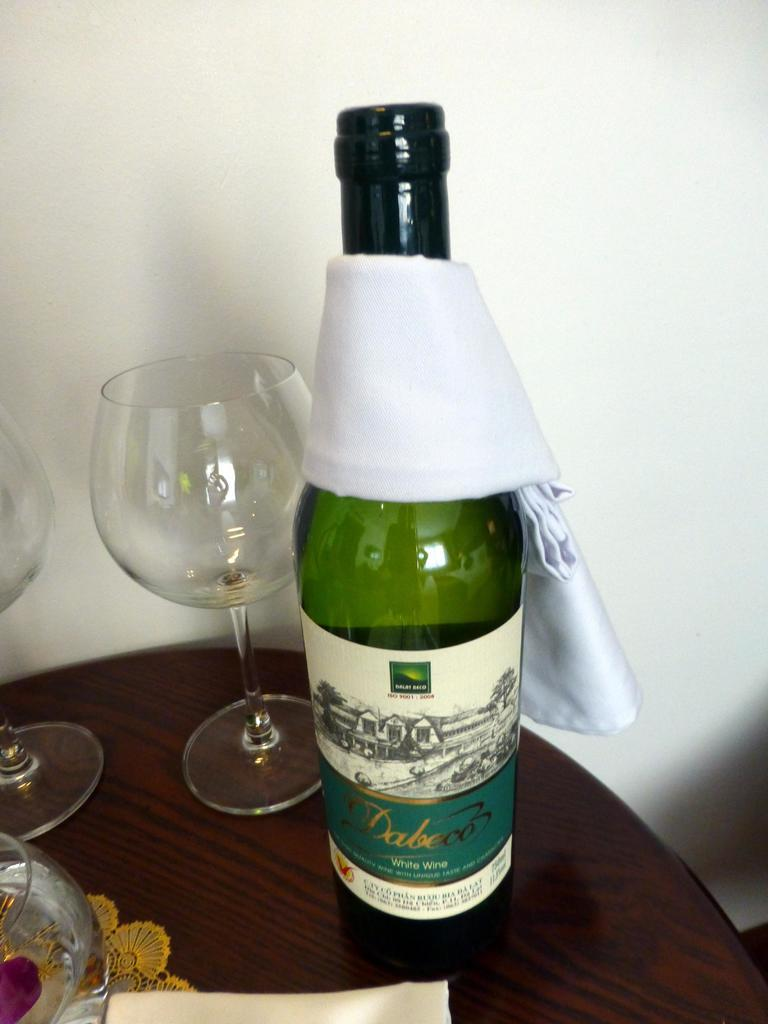What piece of furniture is present in the image? There is a table in the image. What is placed on the table? There is a napkin, glasses, and a bottle on the table. What is the color of the bottle? The bottle is green in color. Is there anything covering the bottle? Yes, there is a cloth on the bottle. What type of army is depicted in the image? There is no army present in the image; it features a table with various items on it. Can you see a nest in the image? There is no nest present in the image. 